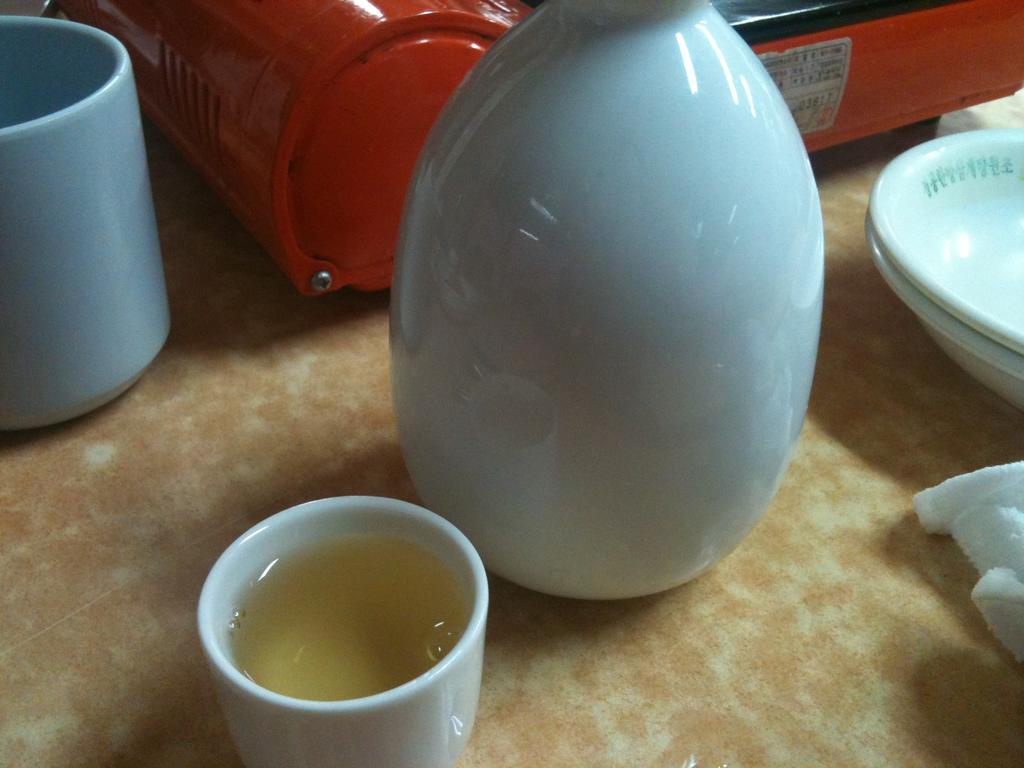What piece of furniture is present in the image? There is a table in the image. What items can be seen on the table? There are cups, a cloth, plates, a jar, and a red color object on the table. What might be used for holding or serving food or drinks? The cups, plates, and jar on the table might be used for holding or serving food or drinks. What type of trousers are being worn by the red color object on the table? The red color object on the table is not a person or an item of clothing, so it cannot be wearing trousers. 